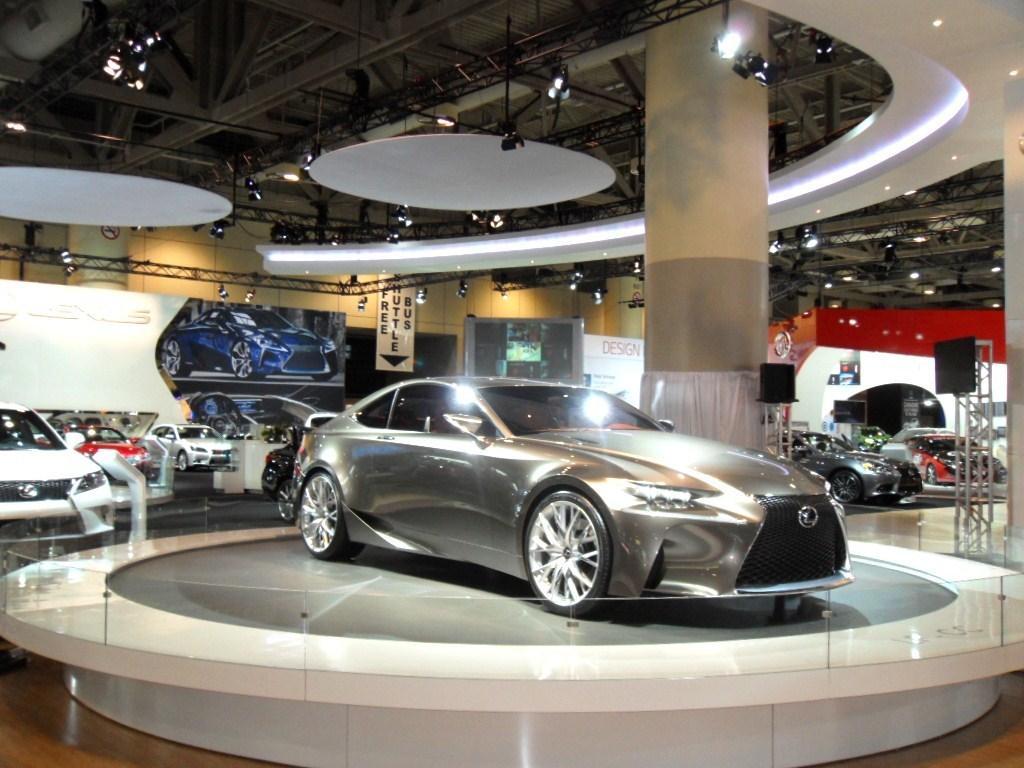Describe this image in one or two sentences. In this image I can see a car which is grey in color on the grey and white colored board. I can see the glass railing around the car. In the background I an see a pillar, the ceiling, few lights and few metal rods to the ceiling, few other cars and the wall. 